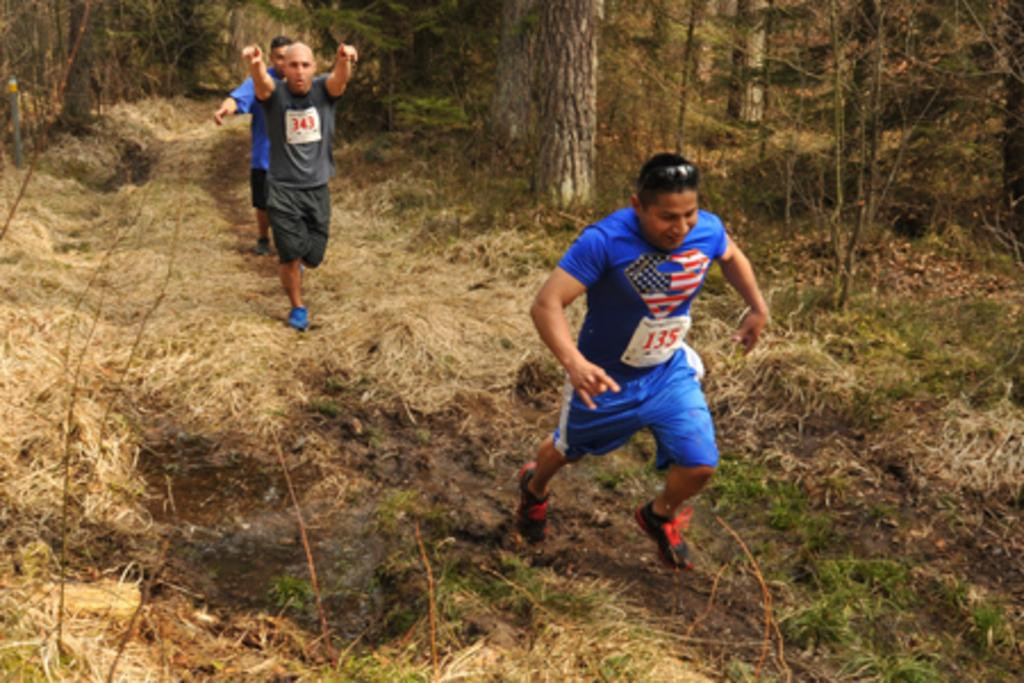What are the people in the image doing? The people in the image are walking on the grass. What type of terrain can be seen in the image? The grass is visible in the image. What can be seen in the background of the image? There are trees in the background of the image. How many giants can be seen walking among the people in the image? There are no giants present in the image; only people can be seen walking on the grass. 